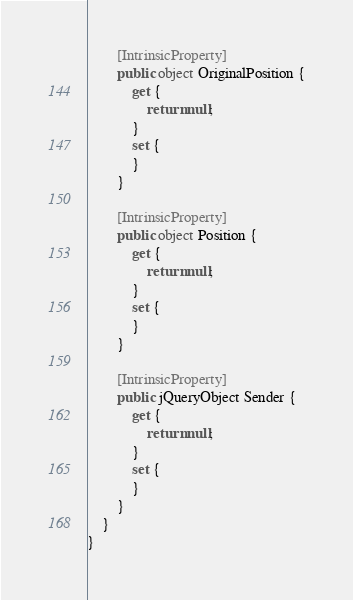Convert code to text. <code><loc_0><loc_0><loc_500><loc_500><_C#_>        [IntrinsicProperty]
        public object OriginalPosition {
            get {
                return null;
            }
            set {
            }
        }

        [IntrinsicProperty]
        public object Position {
            get {
                return null;
            }
            set {
            }
        }

        [IntrinsicProperty]
        public jQueryObject Sender {
            get {
                return null;
            }
            set {
            }
        }
    }
}
</code> 